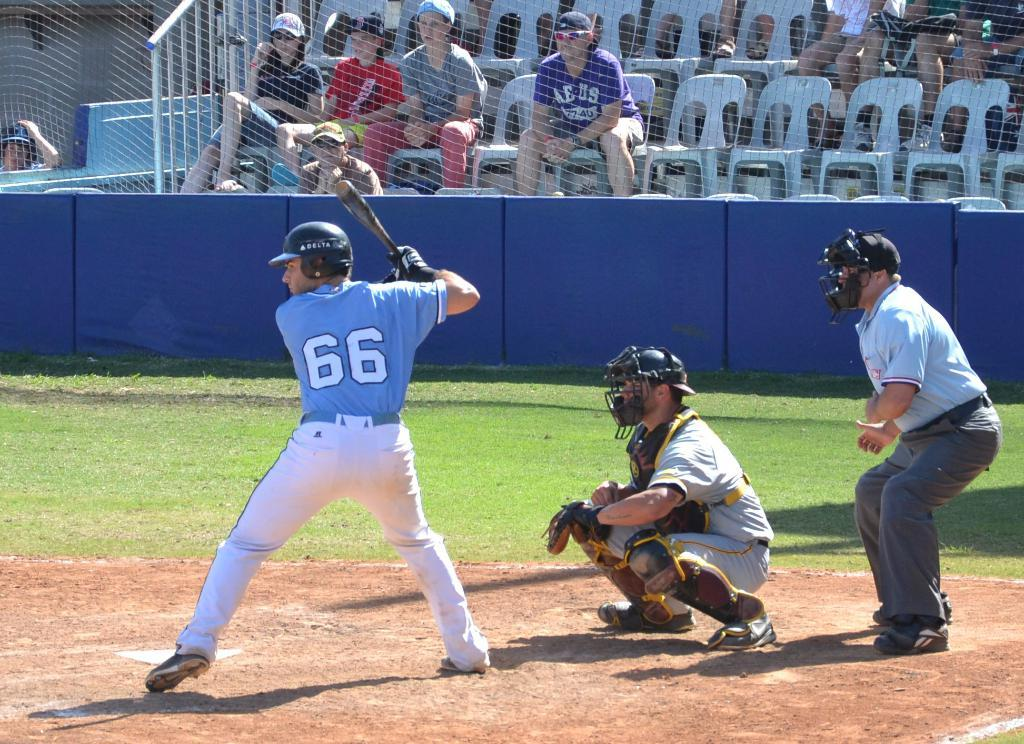<image>
Present a compact description of the photo's key features. A baseball player wearing a Delta helmet and number 66 on the back of his jersey is at the batter's plate. 